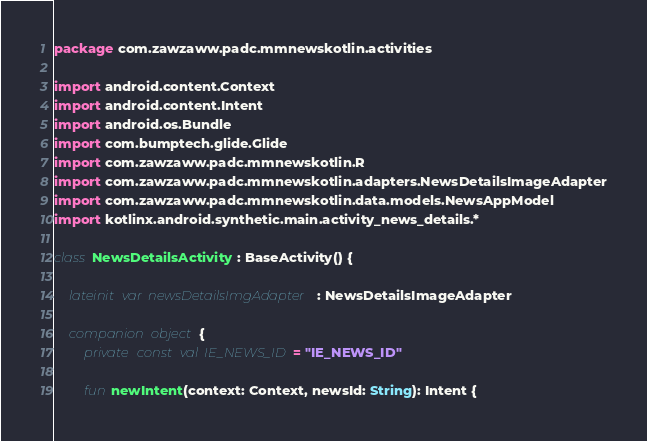<code> <loc_0><loc_0><loc_500><loc_500><_Kotlin_>package com.zawzaww.padc.mmnewskotlin.activities

import android.content.Context
import android.content.Intent
import android.os.Bundle
import com.bumptech.glide.Glide
import com.zawzaww.padc.mmnewskotlin.R
import com.zawzaww.padc.mmnewskotlin.adapters.NewsDetailsImageAdapter
import com.zawzaww.padc.mmnewskotlin.data.models.NewsAppModel
import kotlinx.android.synthetic.main.activity_news_details.*

class NewsDetailsActivity : BaseActivity() {

    lateinit var newsDetailsImgAdapter: NewsDetailsImageAdapter

    companion object {
        private const val IE_NEWS_ID = "IE_NEWS_ID"

        fun newIntent(context: Context, newsId: String): Intent {</code> 